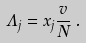<formula> <loc_0><loc_0><loc_500><loc_500>\Lambda _ { j } = x _ { j } \frac { v } { N } \, .</formula> 